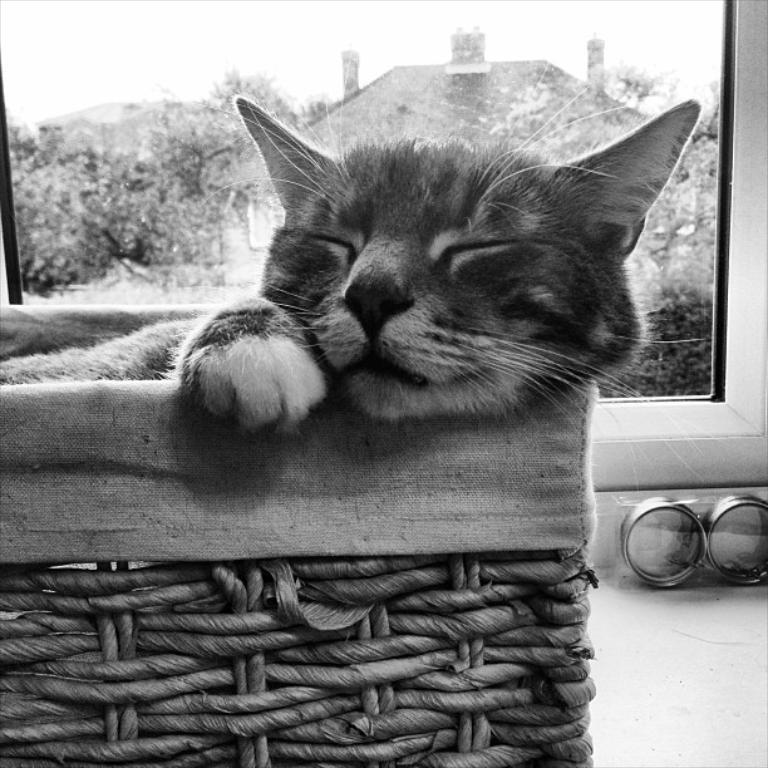In one or two sentences, can you explain what this image depicts? This is a black and white image. In this image we can see cat sleeping on the chair. In the background there are trees, house and sky. 